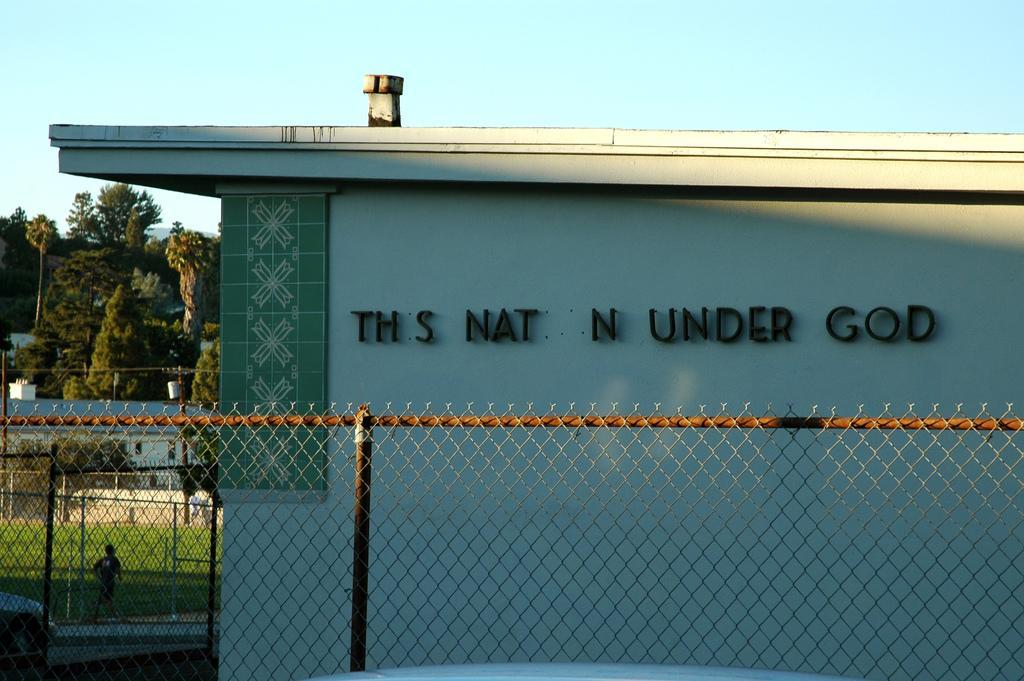Can you describe this image briefly? In this picture we can see metal rods, fence and a house, in the background a person is walking on the grass, and also we can see few poles and trees. 